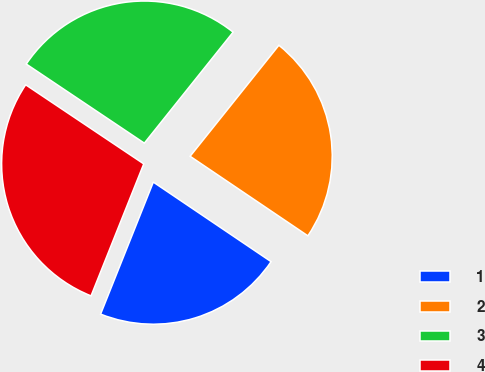Convert chart to OTSL. <chart><loc_0><loc_0><loc_500><loc_500><pie_chart><fcel>1<fcel>2<fcel>3<fcel>4<nl><fcel>21.59%<fcel>23.72%<fcel>26.34%<fcel>28.35%<nl></chart> 